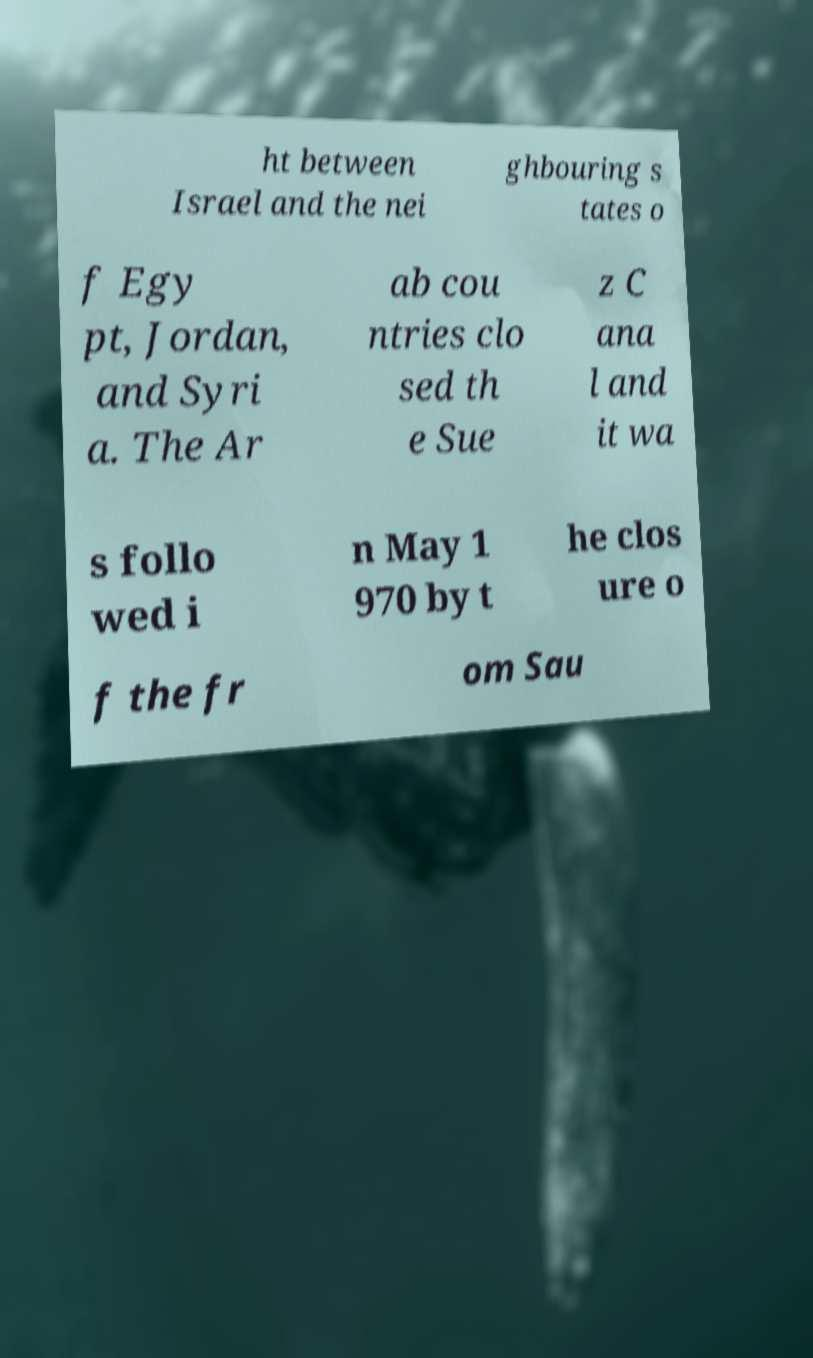I need the written content from this picture converted into text. Can you do that? ht between Israel and the nei ghbouring s tates o f Egy pt, Jordan, and Syri a. The Ar ab cou ntries clo sed th e Sue z C ana l and it wa s follo wed i n May 1 970 by t he clos ure o f the fr om Sau 